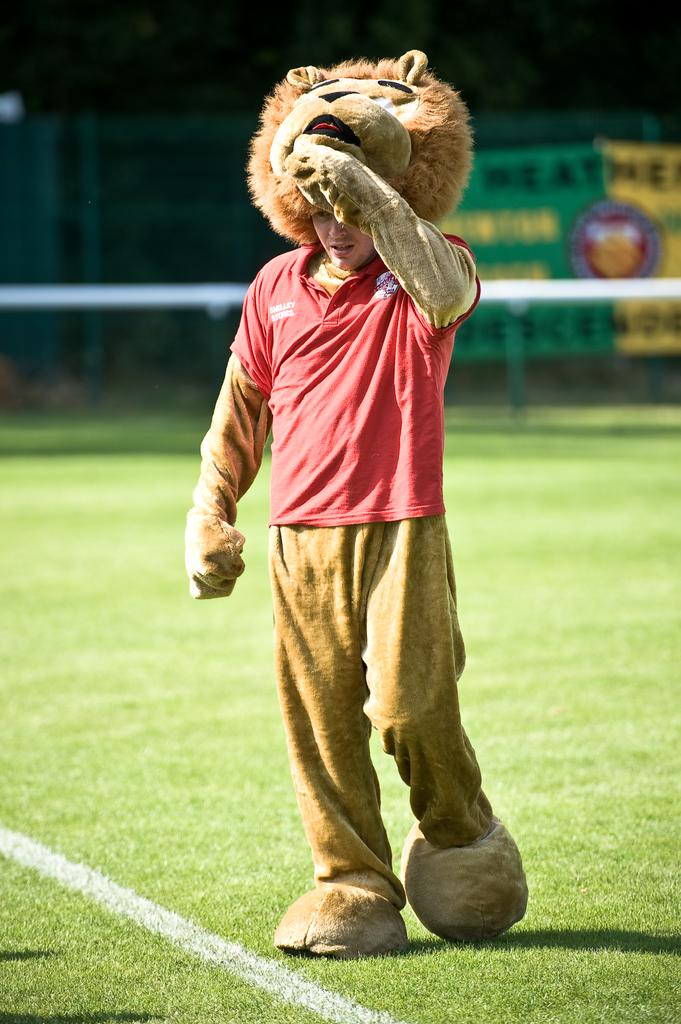What is the person in the image doing? There is a person walking in the image. What type of terrain is visible in the image? There is grass visible in the image. What is the purpose of the structure in the image? There is fencing in the image, which may serve as a boundary or barrier. How would you describe the background of the image? The background of the image is blurred. What color is the stocking on the person's leg in the image? There is no mention of a stocking or any clothing on the person's leg in the image. What breed of dog can be seen running alongside the person in the image? There is no dog present in the image; it only features a person walking. 